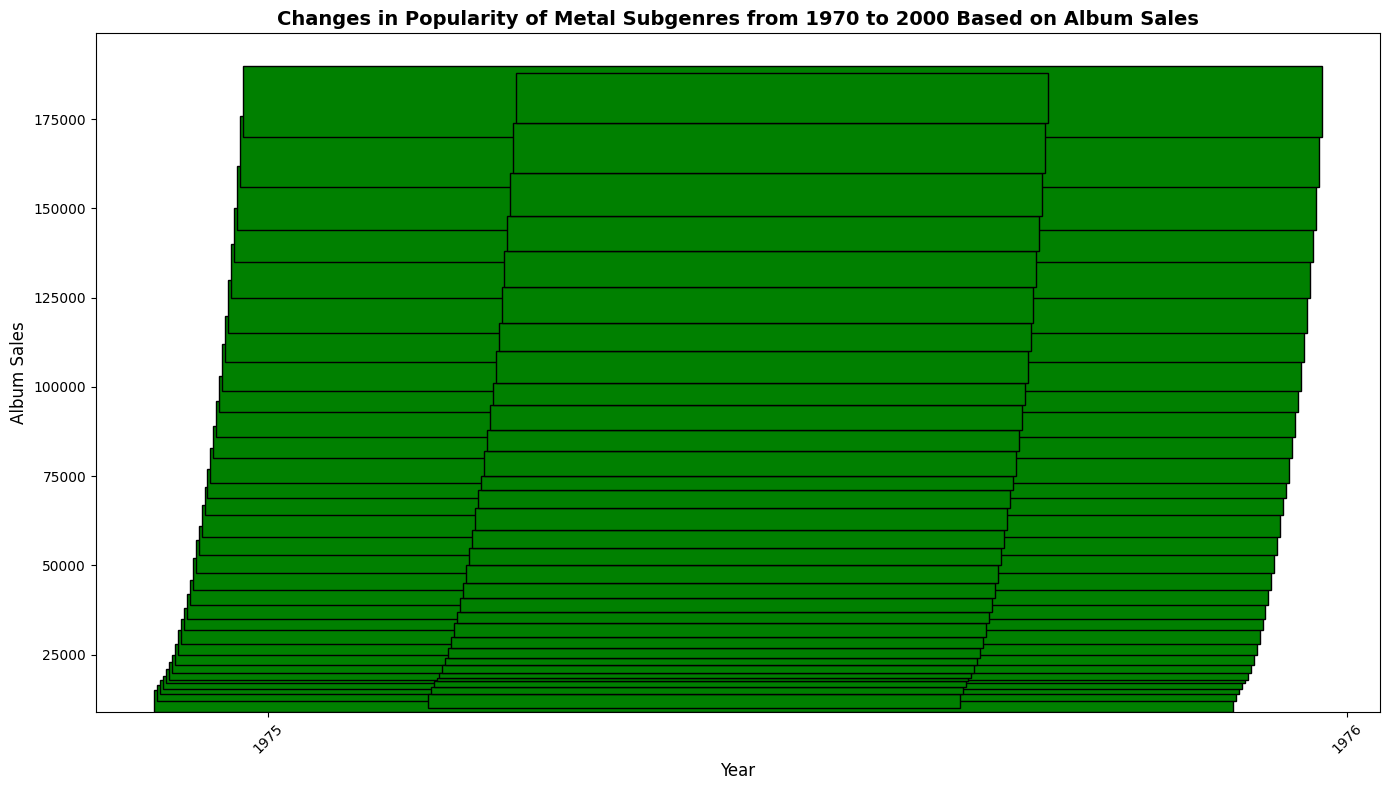What year saw the highest album sales based on the closing value? The closing value of each year represents the end-of-year album sales. By looking at the closing values for each year, the highest value is 188,000 in the year 2000.
Answer: 2000 Which year had the biggest increase in album sales from open to close? The difference between the closing and opening values indicates the yearly increase. The year with the largest increase can be found by comparing these differences: 18,000 in 1992 (101,000 - 83,000).
Answer: 1992 During which year did album sales decline the most from the highest to the lowest point? The maximum decline is the difference between the high and low values. By calculating this difference for each year, 1998 has the steepest decline at 18,000 (162,000 - 144,000).
Answer: 1998 In which years were the closing values higher than the opening values? A closing value higher than the opening value implies an increase in sales for that year. By comparing the close and open values for each year, every year from 1970 to 2000 shows an increase, except 2000.
Answer: 1970-1999 Which year showed no change in album sales based on the open and close values? Checking the open and close values for years to see if they are the same indicates no year had no change; all years have differences in open and close values.
Answer: None What is the average closing value from 1970 to 2000? Sum of all the closing values from 1970 to 2000 is 1,913,000. There are 31 years in the dataset. The average closing value is computed as 1,913,000 / 31.
Answer: 61,710 Which year had the smallest gap between its high and low values? The smallest gap is the difference between the high and the low values. By comparing the gaps, 1970 has the smallest gap (6,000).
Answer: 1970 How many years had a closing value above 100,000? Counting the years where the closing value exceeds 100,000, starting from 1992 (101,000) through 2000 (188,000). This gives us 9 years.
Answer: 9 What’s the median of the closing values from 1970 to 2000? Arrange the closing values in ascending order and find the middle value(s). Since there are 31 data points, the median is the 16th value, which is 41,000 in 1981.
Answer: 41,000 